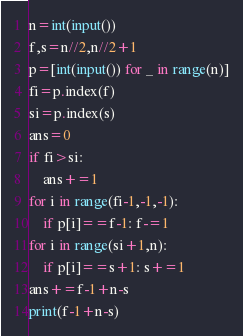<code> <loc_0><loc_0><loc_500><loc_500><_Python_>n=int(input())
f,s=n//2,n//2+1
p=[int(input()) for _ in range(n)]
fi=p.index(f)
si=p.index(s)
ans=0
if fi>si:
    ans+=1
for i in range(fi-1,-1,-1):
    if p[i]==f-1: f-=1
for i in range(si+1,n):
    if p[i]==s+1: s+=1
ans+=f-1+n-s
print(f-1+n-s)</code> 